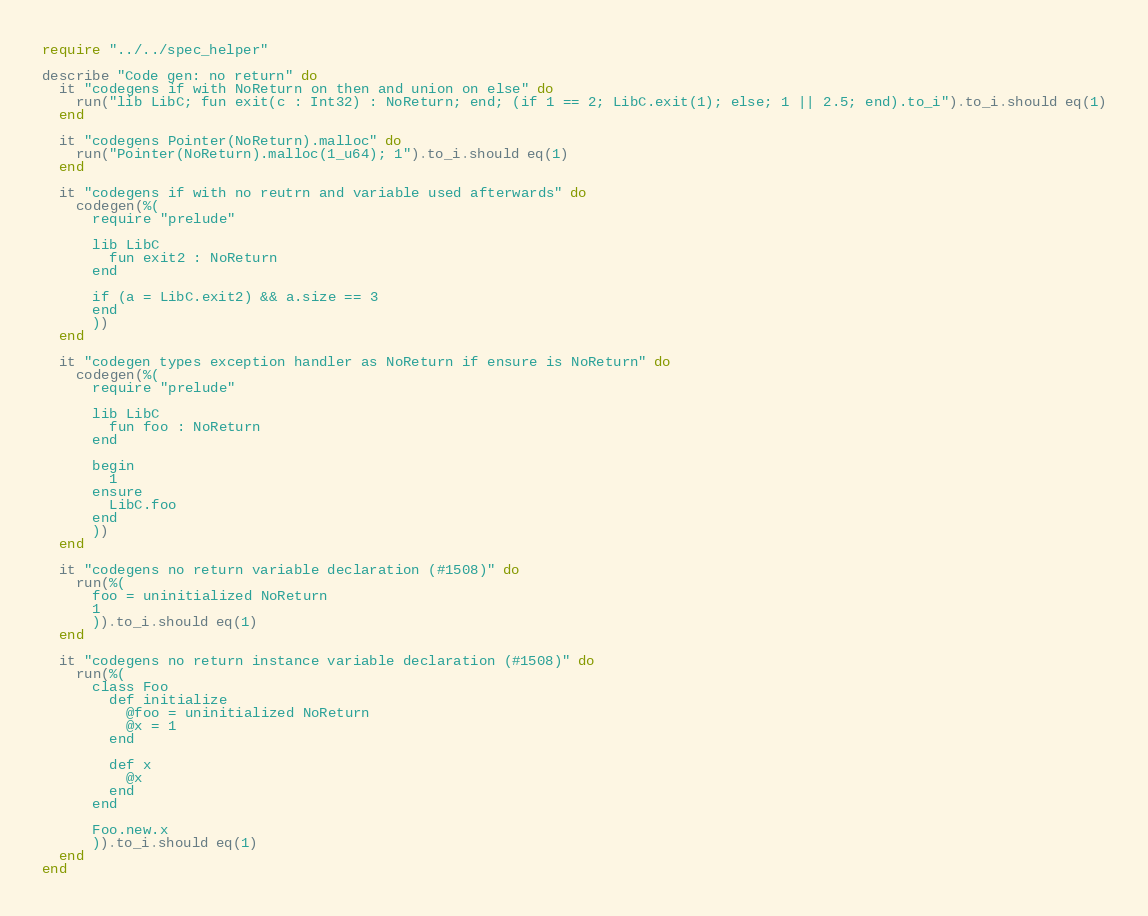Convert code to text. <code><loc_0><loc_0><loc_500><loc_500><_Crystal_>require "../../spec_helper"

describe "Code gen: no return" do
  it "codegens if with NoReturn on then and union on else" do
    run("lib LibC; fun exit(c : Int32) : NoReturn; end; (if 1 == 2; LibC.exit(1); else; 1 || 2.5; end).to_i").to_i.should eq(1)
  end

  it "codegens Pointer(NoReturn).malloc" do
    run("Pointer(NoReturn).malloc(1_u64); 1").to_i.should eq(1)
  end

  it "codegens if with no reutrn and variable used afterwards" do
    codegen(%(
      require "prelude"

      lib LibC
        fun exit2 : NoReturn
      end

      if (a = LibC.exit2) && a.size == 3
      end
      ))
  end

  it "codegen types exception handler as NoReturn if ensure is NoReturn" do
    codegen(%(
      require "prelude"

      lib LibC
        fun foo : NoReturn
      end

      begin
        1
      ensure
        LibC.foo
      end
      ))
  end

  it "codegens no return variable declaration (#1508)" do
    run(%(
      foo = uninitialized NoReturn
      1
      )).to_i.should eq(1)
  end

  it "codegens no return instance variable declaration (#1508)" do
    run(%(
      class Foo
        def initialize
          @foo = uninitialized NoReturn
          @x = 1
        end

        def x
          @x
        end
      end

      Foo.new.x
      )).to_i.should eq(1)
  end
end
</code> 